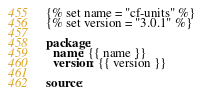<code> <loc_0><loc_0><loc_500><loc_500><_YAML_>{% set name = "cf-units" %}
{% set version = "3.0.1" %}

package:
  name: {{ name }}
  version: {{ version }}

source:</code> 